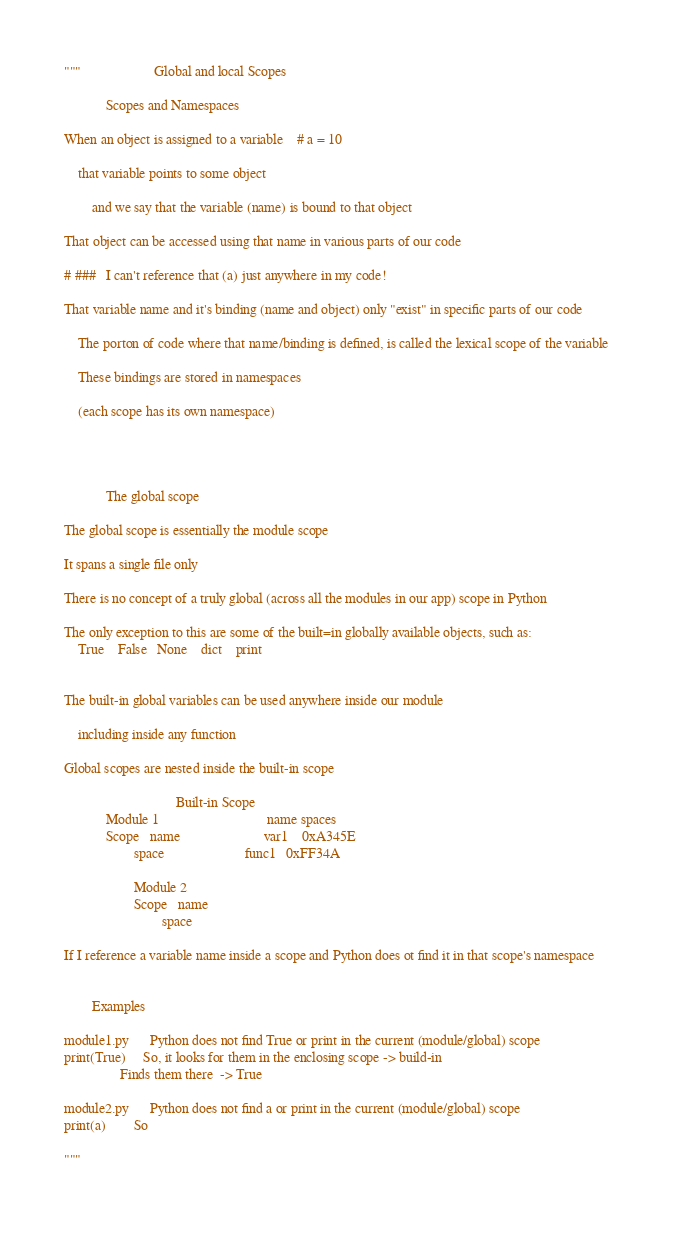Convert code to text. <code><loc_0><loc_0><loc_500><loc_500><_Python_>"""                     Global and local Scopes

            Scopes and Namespaces

When an object is assigned to a variable    # a = 10

    that variable points to some object

        and we say that the variable (name) is bound to that object

That object can be accessed using that name in various parts of our code

# ###   I can't reference that (a) just anywhere in my code!

That variable name and it's binding (name and object) only "exist" in specific parts of our code

    The porton of code where that name/binding is defined, is called the lexical scope of the variable

    These bindings are stored in namespaces

    (each scope has its own namespace)




            The global scope

The global scope is essentially the module scope

It spans a single file only

There is no concept of a truly global (across all the modules in our app) scope in Python

The only exception to this are some of the built=in globally available objects, such as:
    True    False   None    dict    print


The built-in global variables can be used anywhere inside our module

    including inside any function

Global scopes are nested inside the built-in scope

                                Built-in Scope
            Module 1                               name spaces
            Scope   name                        var1    0xA345E
                    space                       func1   0xFF34A

                    Module 2
                    Scope   name
                            space

If I reference a variable name inside a scope and Python does ot find it in that scope's namespace


        Examples

module1.py      Python does not find True or print in the current (module/global) scope
print(True)     So, it looks for them in the enclosing scope -> build-in
                Finds them there  -> True

module2.py      Python does not find a or print in the current (module/global) scope
print(a)        So

"""</code> 